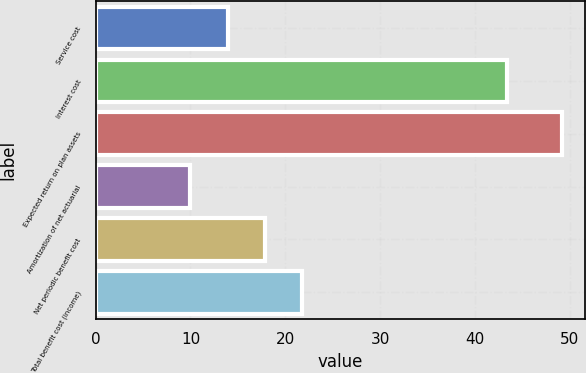Convert chart. <chart><loc_0><loc_0><loc_500><loc_500><bar_chart><fcel>Service cost<fcel>Interest cost<fcel>Expected return on plan assets<fcel>Amortization of net actuarial<fcel>Net periodic benefit cost<fcel>Total benefit cost (income)<nl><fcel>13.92<fcel>43.4<fcel>49.2<fcel>10<fcel>17.84<fcel>21.76<nl></chart> 